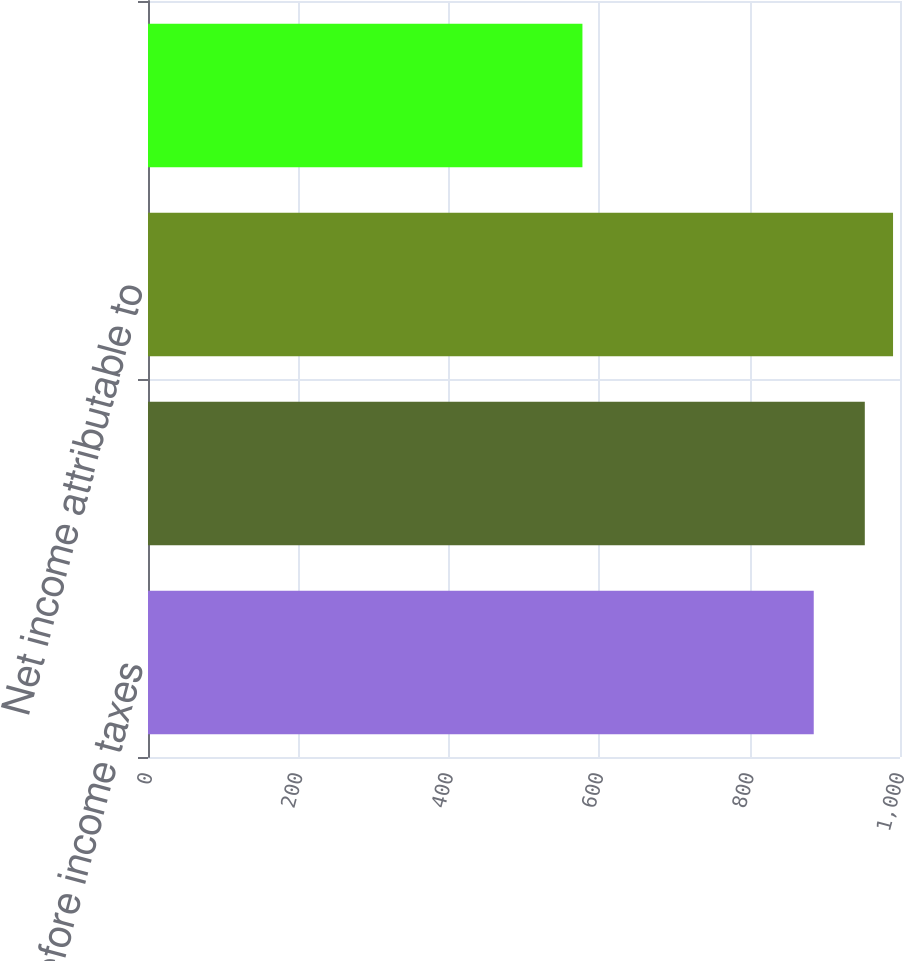Convert chart to OTSL. <chart><loc_0><loc_0><loc_500><loc_500><bar_chart><fcel>Income before income taxes<fcel>Consolidated net income<fcel>Net income attributable to<fcel>Comprehensive income<nl><fcel>885.3<fcel>953.2<fcel>990.75<fcel>577.7<nl></chart> 